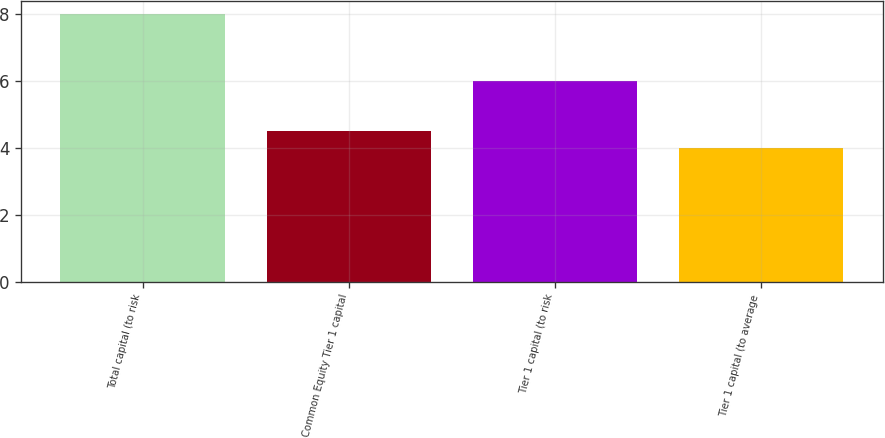<chart> <loc_0><loc_0><loc_500><loc_500><bar_chart><fcel>Total capital (to risk<fcel>Common Equity Tier 1 capital<fcel>Tier 1 capital (to risk<fcel>Tier 1 capital (to average<nl><fcel>8<fcel>4.5<fcel>6<fcel>4<nl></chart> 